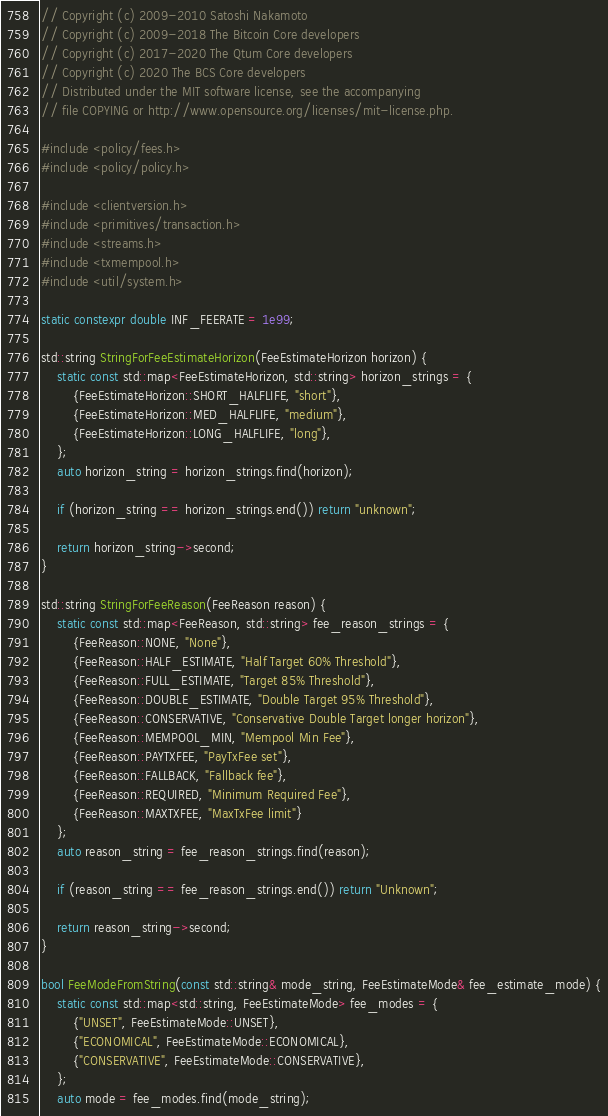<code> <loc_0><loc_0><loc_500><loc_500><_C++_>// Copyright (c) 2009-2010 Satoshi Nakamoto
// Copyright (c) 2009-2018 The Bitcoin Core developers
// Copyright (c) 2017-2020 The Qtum Core developers
// Copyright (c) 2020 The BCS Core developers
// Distributed under the MIT software license, see the accompanying
// file COPYING or http://www.opensource.org/licenses/mit-license.php.

#include <policy/fees.h>
#include <policy/policy.h>

#include <clientversion.h>
#include <primitives/transaction.h>
#include <streams.h>
#include <txmempool.h>
#include <util/system.h>

static constexpr double INF_FEERATE = 1e99;

std::string StringForFeeEstimateHorizon(FeeEstimateHorizon horizon) {
    static const std::map<FeeEstimateHorizon, std::string> horizon_strings = {
        {FeeEstimateHorizon::SHORT_HALFLIFE, "short"},
        {FeeEstimateHorizon::MED_HALFLIFE, "medium"},
        {FeeEstimateHorizon::LONG_HALFLIFE, "long"},
    };
    auto horizon_string = horizon_strings.find(horizon);

    if (horizon_string == horizon_strings.end()) return "unknown";

    return horizon_string->second;
}

std::string StringForFeeReason(FeeReason reason) {
    static const std::map<FeeReason, std::string> fee_reason_strings = {
        {FeeReason::NONE, "None"},
        {FeeReason::HALF_ESTIMATE, "Half Target 60% Threshold"},
        {FeeReason::FULL_ESTIMATE, "Target 85% Threshold"},
        {FeeReason::DOUBLE_ESTIMATE, "Double Target 95% Threshold"},
        {FeeReason::CONSERVATIVE, "Conservative Double Target longer horizon"},
        {FeeReason::MEMPOOL_MIN, "Mempool Min Fee"},
        {FeeReason::PAYTXFEE, "PayTxFee set"},
        {FeeReason::FALLBACK, "Fallback fee"},
        {FeeReason::REQUIRED, "Minimum Required Fee"},
        {FeeReason::MAXTXFEE, "MaxTxFee limit"}
    };
    auto reason_string = fee_reason_strings.find(reason);

    if (reason_string == fee_reason_strings.end()) return "Unknown";

    return reason_string->second;
}

bool FeeModeFromString(const std::string& mode_string, FeeEstimateMode& fee_estimate_mode) {
    static const std::map<std::string, FeeEstimateMode> fee_modes = {
        {"UNSET", FeeEstimateMode::UNSET},
        {"ECONOMICAL", FeeEstimateMode::ECONOMICAL},
        {"CONSERVATIVE", FeeEstimateMode::CONSERVATIVE},
    };
    auto mode = fee_modes.find(mode_string);
</code> 